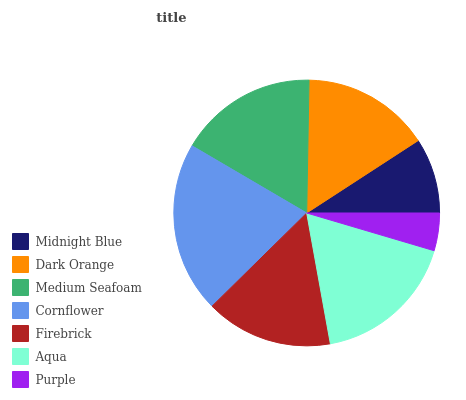Is Purple the minimum?
Answer yes or no. Yes. Is Cornflower the maximum?
Answer yes or no. Yes. Is Dark Orange the minimum?
Answer yes or no. No. Is Dark Orange the maximum?
Answer yes or no. No. Is Dark Orange greater than Midnight Blue?
Answer yes or no. Yes. Is Midnight Blue less than Dark Orange?
Answer yes or no. Yes. Is Midnight Blue greater than Dark Orange?
Answer yes or no. No. Is Dark Orange less than Midnight Blue?
Answer yes or no. No. Is Dark Orange the high median?
Answer yes or no. Yes. Is Dark Orange the low median?
Answer yes or no. Yes. Is Purple the high median?
Answer yes or no. No. Is Aqua the low median?
Answer yes or no. No. 